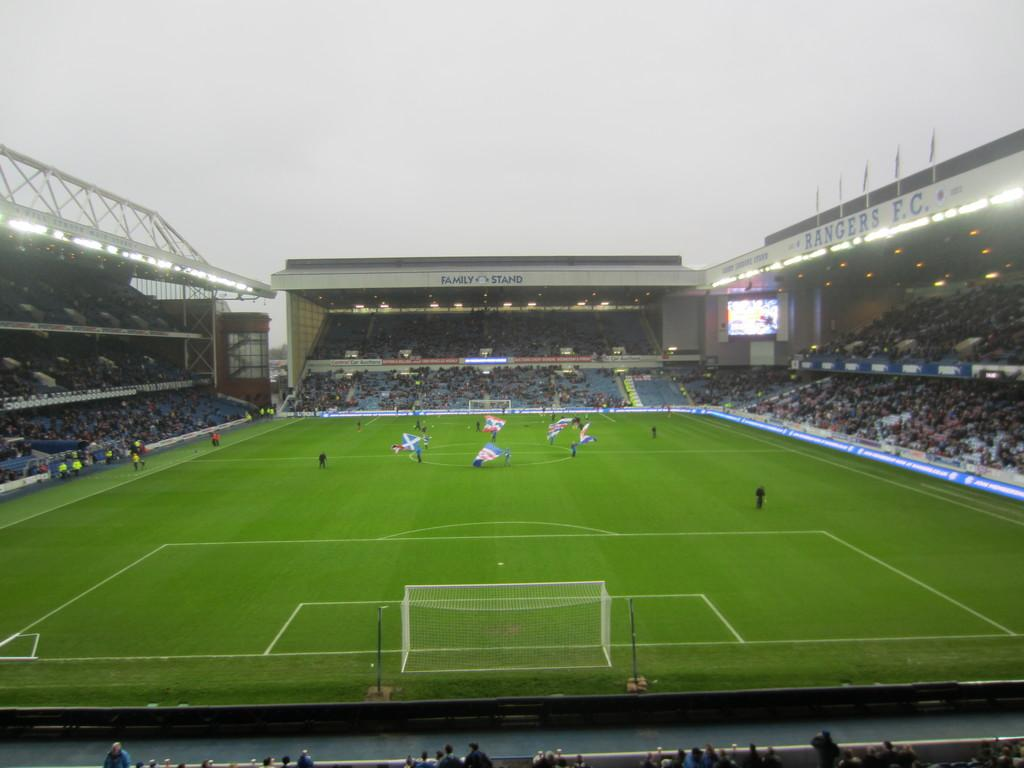<image>
Summarize the visual content of the image. One side of an outdoor stadium is labeled, "RANGERS F.C." 